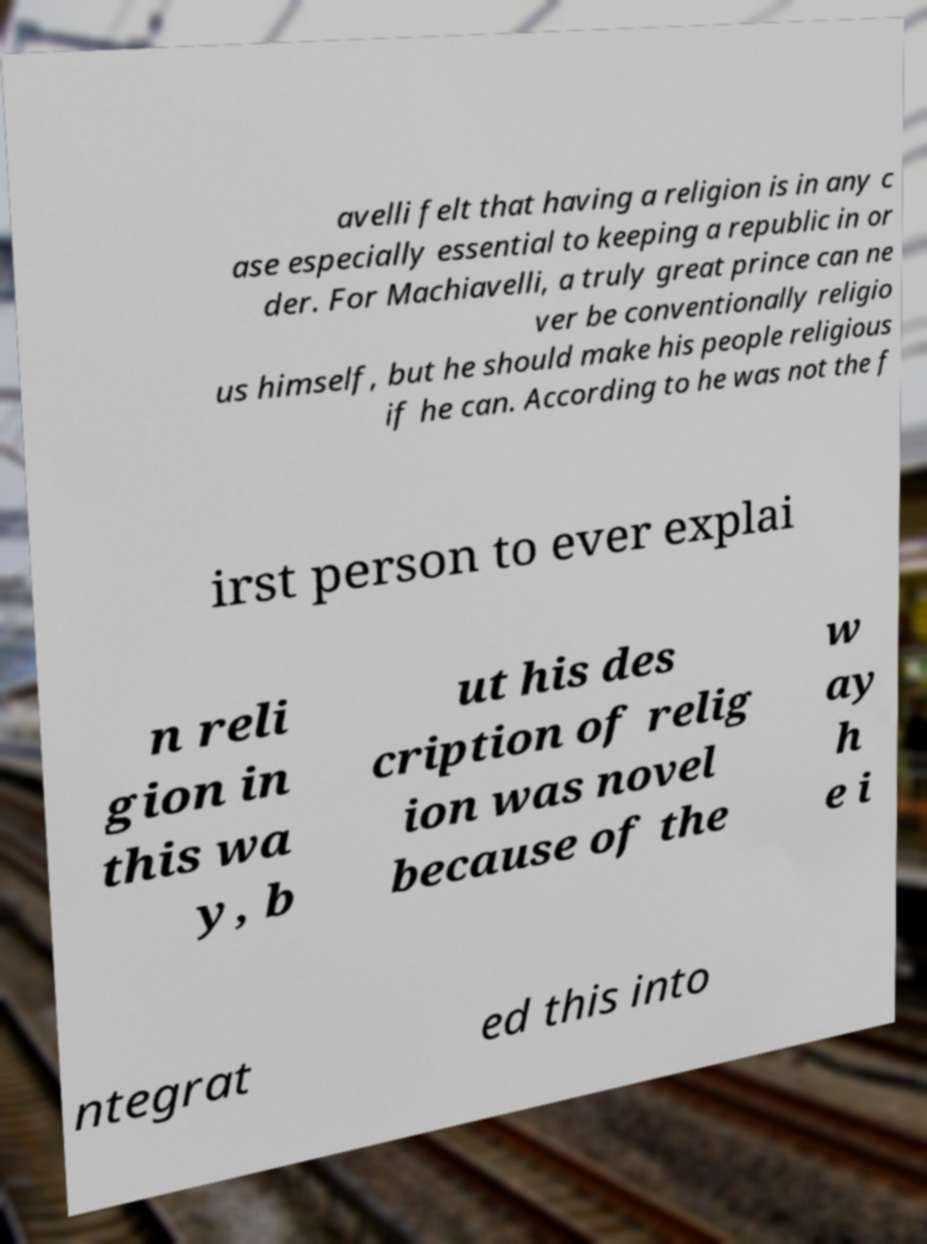Can you accurately transcribe the text from the provided image for me? avelli felt that having a religion is in any c ase especially essential to keeping a republic in or der. For Machiavelli, a truly great prince can ne ver be conventionally religio us himself, but he should make his people religious if he can. According to he was not the f irst person to ever explai n reli gion in this wa y, b ut his des cription of relig ion was novel because of the w ay h e i ntegrat ed this into 